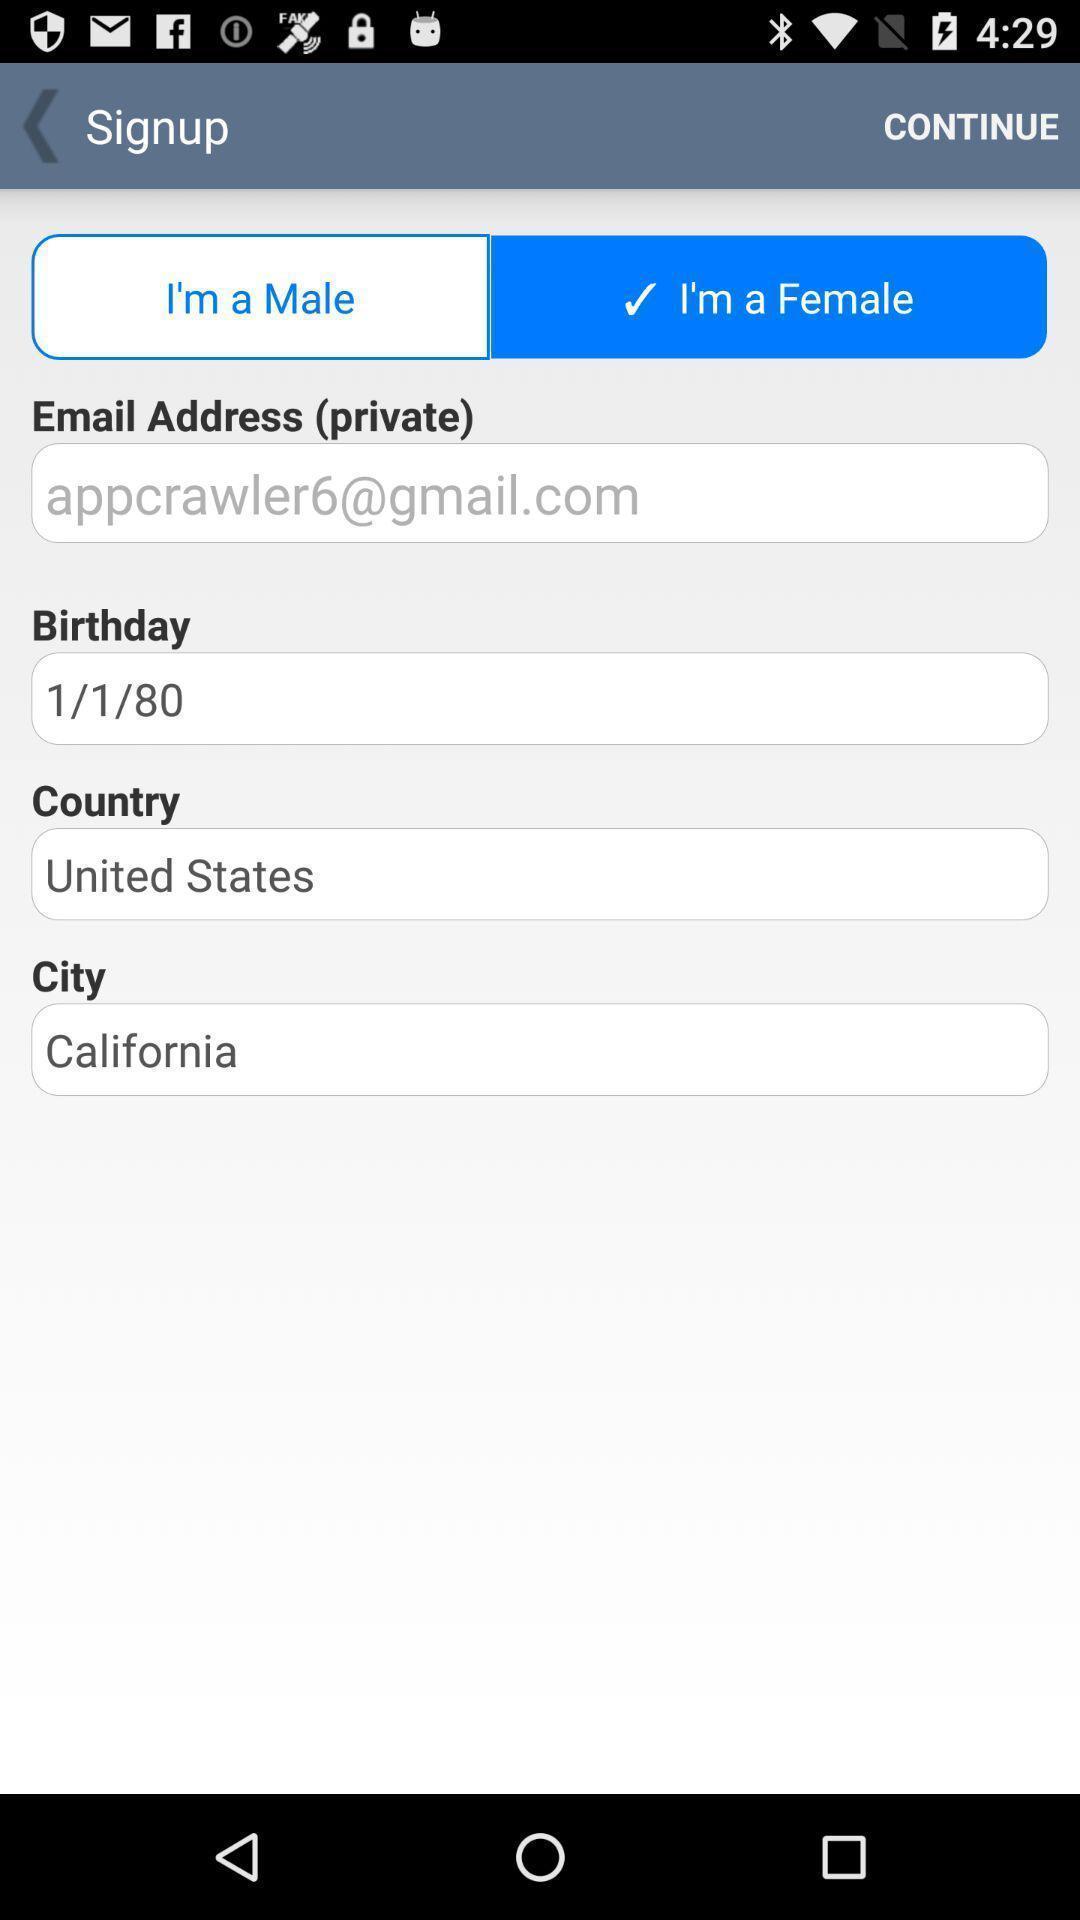What is the overall content of this screenshot? Signup page of a website. 